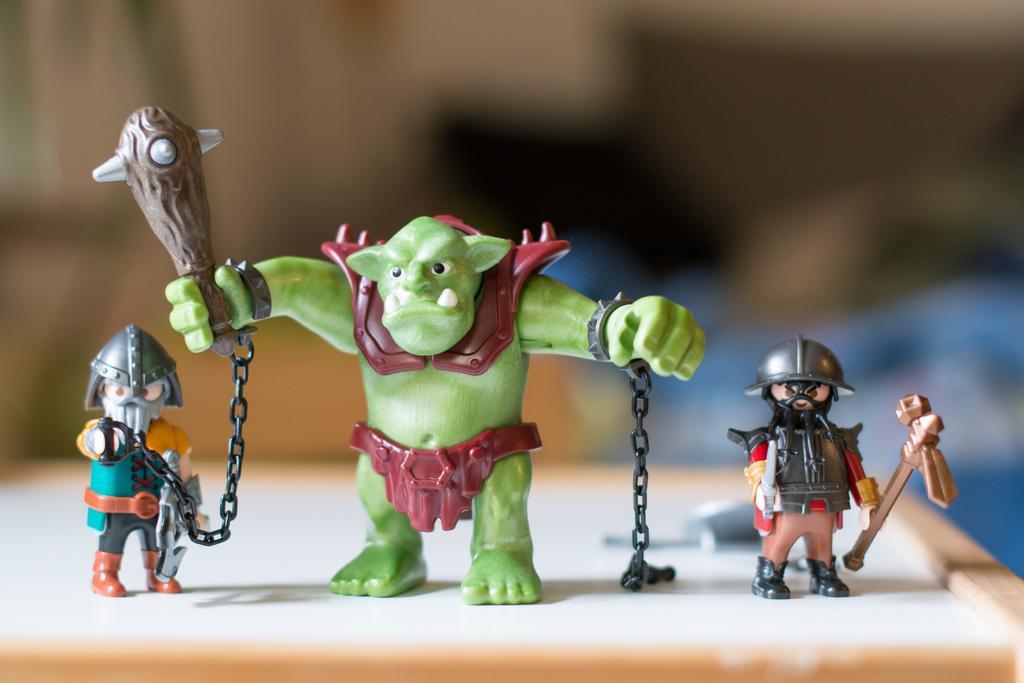Can you describe this image briefly? In this image I can see few toys on a wooden surface. The background is blurred. 